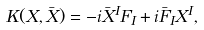Convert formula to latex. <formula><loc_0><loc_0><loc_500><loc_500>K ( X , \bar { X } ) = - i \bar { X } ^ { I } F _ { I } + i \bar { F } _ { I } X ^ { I } ,</formula> 